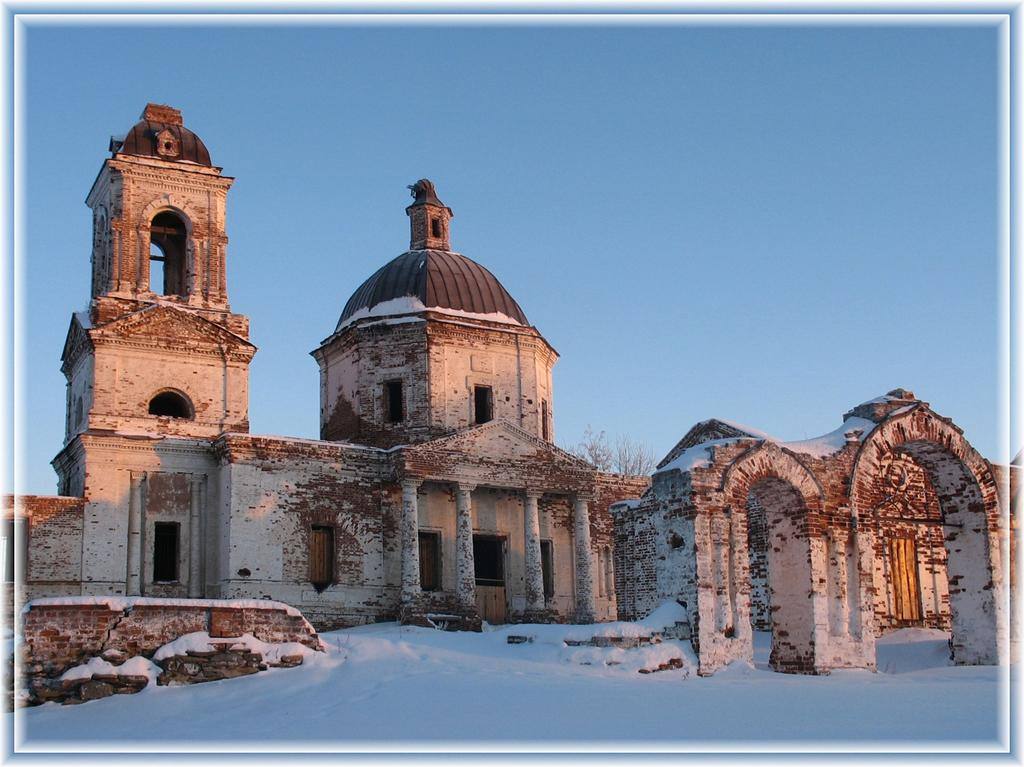What is the main structure in the center of the image? There is a building in the center of the image. What other architectural feature can be seen in the image? There is a wall in the image. What type of weather is depicted in the image? Snow is present at the bottom of the image, indicating a snowy scene. What type of vegetation is visible in the image? There are plants visible in the image. What is visible at the top of the image? The sky is visible at the top of the image. What type of arch can be seen in the image? There is no arch present in the image. What type of market is depicted in the image? There is no market depicted in the image. 